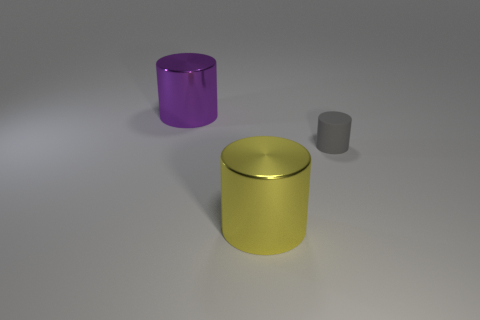Add 1 yellow shiny cylinders. How many objects exist? 4 Subtract all large cylinders. How many cylinders are left? 1 Subtract all yellow cylinders. How many cylinders are left? 2 Subtract 3 cylinders. How many cylinders are left? 0 Add 2 small gray things. How many small gray things are left? 3 Add 3 purple shiny things. How many purple shiny things exist? 4 Subtract 0 red blocks. How many objects are left? 3 Subtract all gray cylinders. Subtract all purple cubes. How many cylinders are left? 2 Subtract all cyan shiny objects. Subtract all cylinders. How many objects are left? 0 